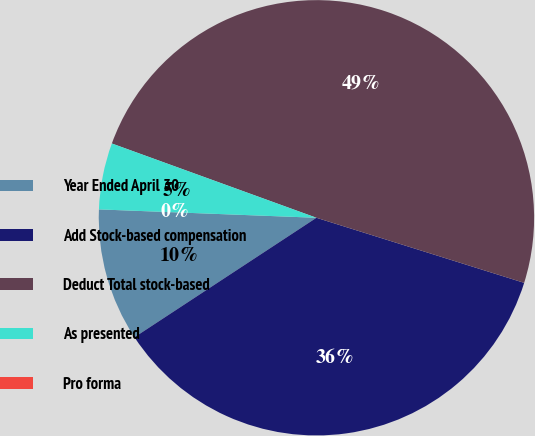<chart> <loc_0><loc_0><loc_500><loc_500><pie_chart><fcel>Year Ended April 30<fcel>Add Stock-based compensation<fcel>Deduct Total stock-based<fcel>As presented<fcel>Pro forma<nl><fcel>9.86%<fcel>35.92%<fcel>49.29%<fcel>4.93%<fcel>0.0%<nl></chart> 